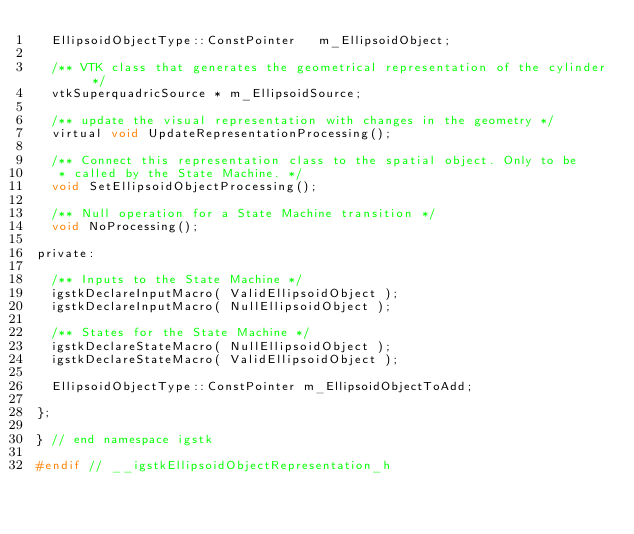<code> <loc_0><loc_0><loc_500><loc_500><_C_>  EllipsoidObjectType::ConstPointer   m_EllipsoidObject;

  /** VTK class that generates the geometrical representation of the cylinder */
  vtkSuperquadricSource * m_EllipsoidSource;

  /** update the visual representation with changes in the geometry */
  virtual void UpdateRepresentationProcessing();

  /** Connect this representation class to the spatial object. Only to be
   * called by the State Machine. */
  void SetEllipsoidObjectProcessing(); 

  /** Null operation for a State Machine transition */
  void NoProcessing();

private:

  /** Inputs to the State Machine */
  igstkDeclareInputMacro( ValidEllipsoidObject );
  igstkDeclareInputMacro( NullEllipsoidObject );
  
  /** States for the State Machine */
  igstkDeclareStateMacro( NullEllipsoidObject );
  igstkDeclareStateMacro( ValidEllipsoidObject );

  EllipsoidObjectType::ConstPointer m_EllipsoidObjectToAdd;

};

} // end namespace igstk

#endif // __igstkEllipsoidObjectRepresentation_h
</code> 